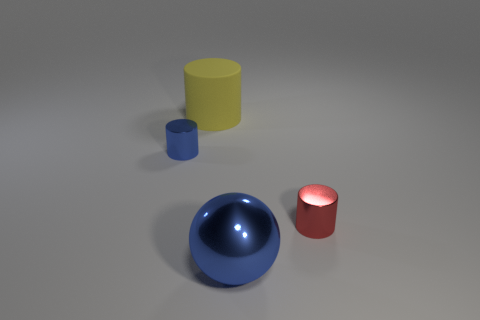Add 4 small balls. How many objects exist? 8 Subtract all small shiny cylinders. How many cylinders are left? 1 Subtract all balls. How many objects are left? 3 Subtract 2 cylinders. How many cylinders are left? 1 Subtract all green cylinders. Subtract all green cubes. How many cylinders are left? 3 Subtract all brown balls. How many blue cylinders are left? 1 Subtract all big spheres. Subtract all tiny metallic objects. How many objects are left? 1 Add 3 big shiny things. How many big shiny things are left? 4 Add 2 blue cylinders. How many blue cylinders exist? 3 Subtract all blue cylinders. How many cylinders are left? 2 